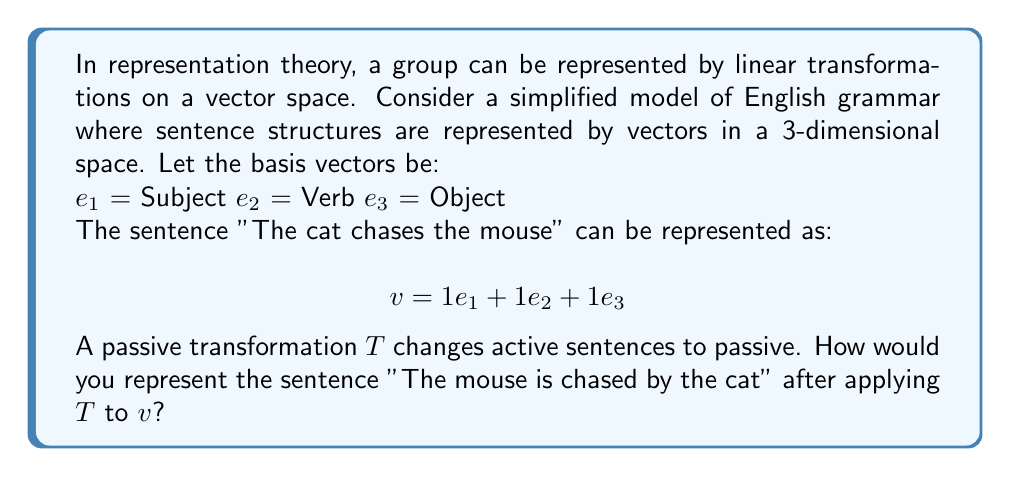Give your solution to this math problem. To solve this problem, we need to understand how the passive transformation $T$ affects our vector representation:

1. In the passive voice, the object becomes the subject, and the subject becomes the object introduced by "by".
2. The verb changes to a form of "to be" + past participle.

Let's represent this transformation as a matrix $T$:

$$T = \begin{pmatrix}
0 & 0 & 1 \\
1 & 1 & 0 \\
1 & 0 & 0
\end{pmatrix}$$

Here's how $T$ works:
- The first row (0, 0, 1) moves the object to the subject position.
- The second row (1, 1, 0) keeps the verb and adds the "to be" auxiliary.
- The third row (1, 0, 0) moves the subject to the object position.

Now, let's apply $T$ to our original vector $v$:

$$T v = \begin{pmatrix}
0 & 0 & 1 \\
1 & 1 & 0 \\
1 & 0 & 0
\end{pmatrix} \begin{pmatrix}
1 \\
1 \\
1
\end{pmatrix} = \begin{pmatrix}
1 \\
2 \\
1
\end{pmatrix}$$

This results in a new vector $w = 1e_1 + 2e_2 + 1e_3$, which represents our passive sentence "The mouse is chased by the cat".

The coefficient 2 for $e_2$ represents the two-part verb structure in passive voice ("is chased").
Answer: $w = 1e_1 + 2e_2 + 1e_3$ 